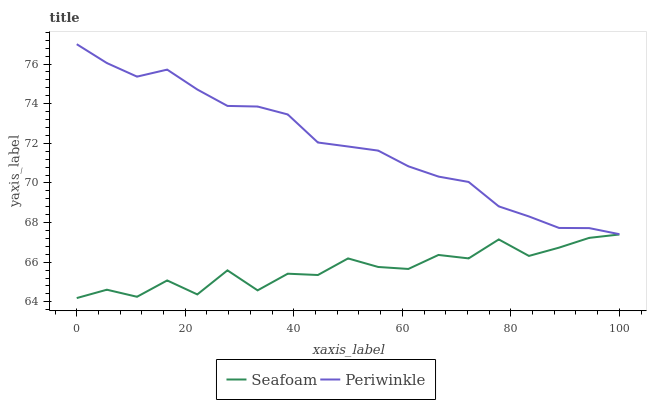Does Seafoam have the minimum area under the curve?
Answer yes or no. Yes. Does Periwinkle have the maximum area under the curve?
Answer yes or no. Yes. Does Seafoam have the maximum area under the curve?
Answer yes or no. No. Is Periwinkle the smoothest?
Answer yes or no. Yes. Is Seafoam the roughest?
Answer yes or no. Yes. Is Seafoam the smoothest?
Answer yes or no. No. Does Seafoam have the lowest value?
Answer yes or no. Yes. Does Periwinkle have the highest value?
Answer yes or no. Yes. Does Seafoam have the highest value?
Answer yes or no. No. Is Seafoam less than Periwinkle?
Answer yes or no. Yes. Is Periwinkle greater than Seafoam?
Answer yes or no. Yes. Does Seafoam intersect Periwinkle?
Answer yes or no. No. 